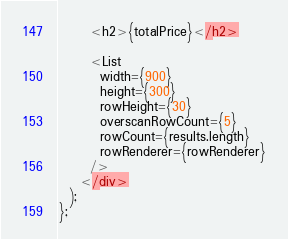<code> <loc_0><loc_0><loc_500><loc_500><_TypeScript_>      <h2>{totalPrice}</h2>

      <List
        width={900}
        height={300}
        rowHeight={30}
        overscanRowCount={5}
        rowCount={results.length}
        rowRenderer={rowRenderer}
      />
    </div>
  );
};</code> 